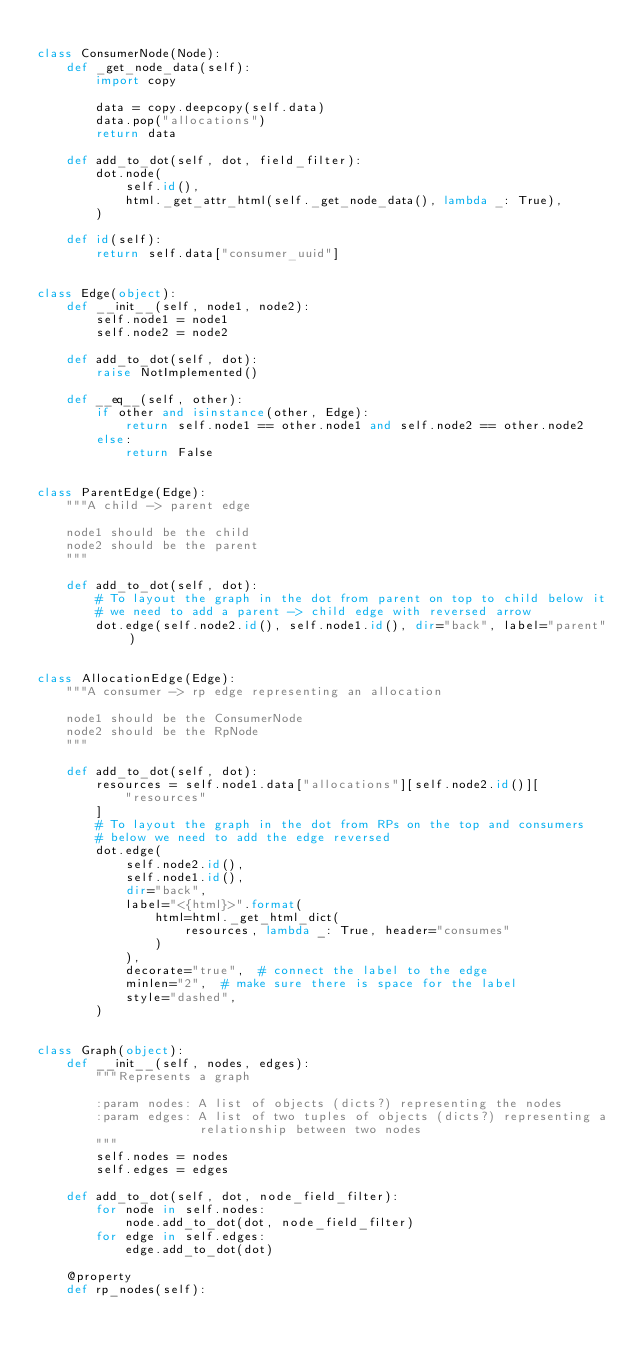<code> <loc_0><loc_0><loc_500><loc_500><_Python_>
class ConsumerNode(Node):
    def _get_node_data(self):
        import copy

        data = copy.deepcopy(self.data)
        data.pop("allocations")
        return data

    def add_to_dot(self, dot, field_filter):
        dot.node(
            self.id(),
            html._get_attr_html(self._get_node_data(), lambda _: True),
        )

    def id(self):
        return self.data["consumer_uuid"]


class Edge(object):
    def __init__(self, node1, node2):
        self.node1 = node1
        self.node2 = node2

    def add_to_dot(self, dot):
        raise NotImplemented()

    def __eq__(self, other):
        if other and isinstance(other, Edge):
            return self.node1 == other.node1 and self.node2 == other.node2
        else:
            return False


class ParentEdge(Edge):
    """A child -> parent edge

    node1 should be the child
    node2 should be the parent
    """

    def add_to_dot(self, dot):
        # To layout the graph in the dot from parent on top to child below it
        # we need to add a parent -> child edge with reversed arrow
        dot.edge(self.node2.id(), self.node1.id(), dir="back", label="parent")


class AllocationEdge(Edge):
    """A consumer -> rp edge representing an allocation

    node1 should be the ConsumerNode
    node2 should be the RpNode
    """

    def add_to_dot(self, dot):
        resources = self.node1.data["allocations"][self.node2.id()][
            "resources"
        ]
        # To layout the graph in the dot from RPs on the top and consumers
        # below we need to add the edge reversed
        dot.edge(
            self.node2.id(),
            self.node1.id(),
            dir="back",
            label="<{html}>".format(
                html=html._get_html_dict(
                    resources, lambda _: True, header="consumes"
                )
            ),
            decorate="true",  # connect the label to the edge
            minlen="2",  # make sure there is space for the label
            style="dashed",
        )


class Graph(object):
    def __init__(self, nodes, edges):
        """Represents a graph

        :param nodes: A list of objects (dicts?) representing the nodes
        :param edges: A list of two tuples of objects (dicts?) representing a
                      relationship between two nodes
        """
        self.nodes = nodes
        self.edges = edges

    def add_to_dot(self, dot, node_field_filter):
        for node in self.nodes:
            node.add_to_dot(dot, node_field_filter)
        for edge in self.edges:
            edge.add_to_dot(dot)

    @property
    def rp_nodes(self):</code> 